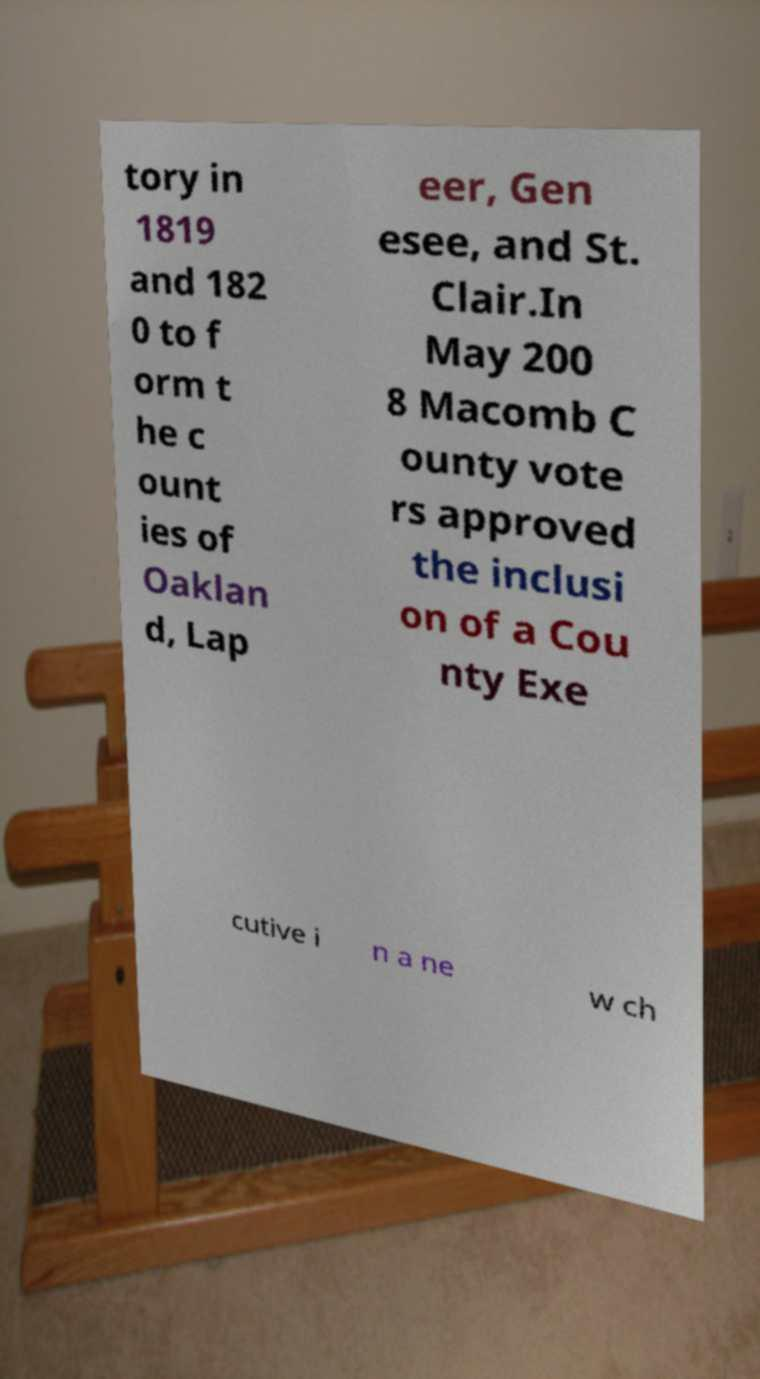What messages or text are displayed in this image? I need them in a readable, typed format. tory in 1819 and 182 0 to f orm t he c ount ies of Oaklan d, Lap eer, Gen esee, and St. Clair.In May 200 8 Macomb C ounty vote rs approved the inclusi on of a Cou nty Exe cutive i n a ne w ch 